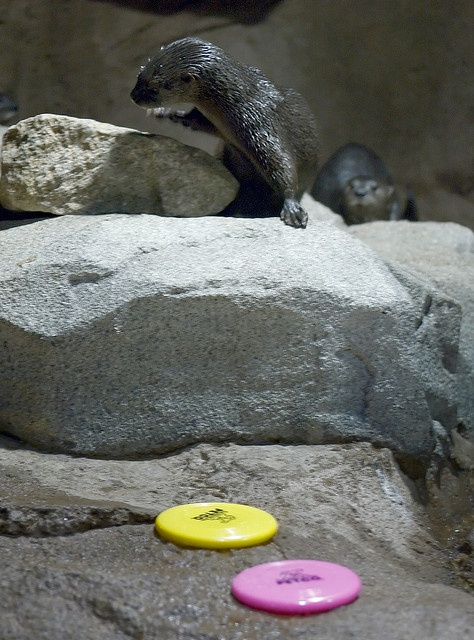Describe the objects in this image and their specific colors. I can see frisbee in black, violet, magenta, maroon, and purple tones and frisbee in black, khaki, and olive tones in this image. 